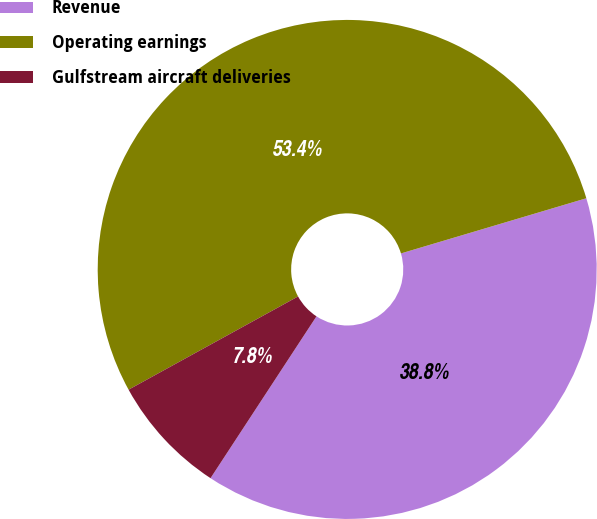Convert chart. <chart><loc_0><loc_0><loc_500><loc_500><pie_chart><fcel>Revenue<fcel>Operating earnings<fcel>Gulfstream aircraft deliveries<nl><fcel>38.83%<fcel>53.4%<fcel>7.77%<nl></chart> 